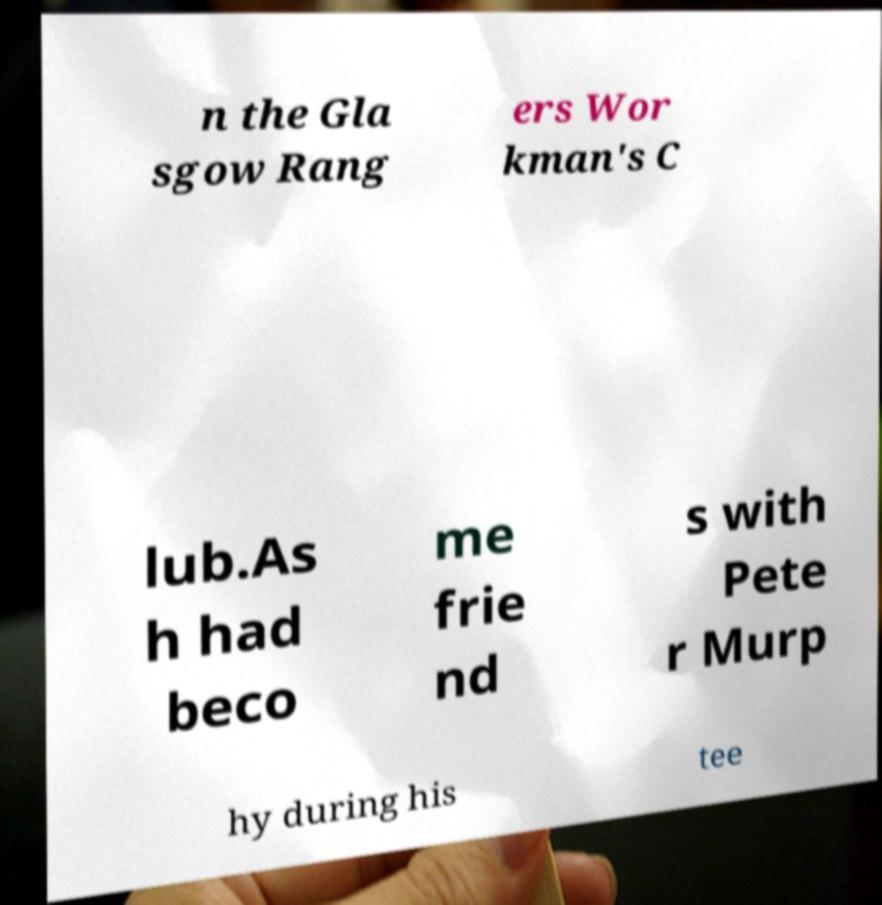Could you extract and type out the text from this image? n the Gla sgow Rang ers Wor kman's C lub.As h had beco me frie nd s with Pete r Murp hy during his tee 